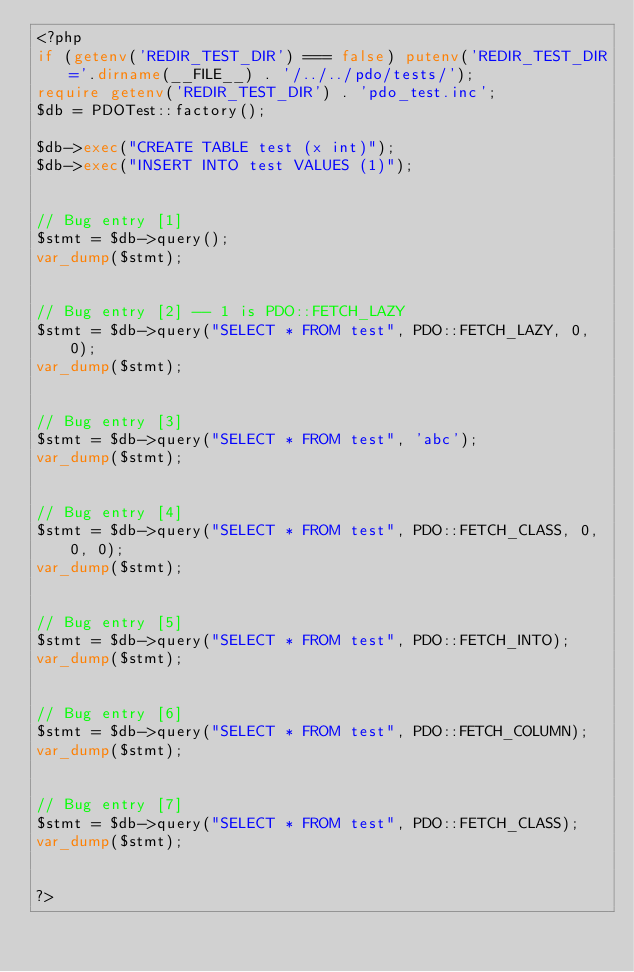Convert code to text. <code><loc_0><loc_0><loc_500><loc_500><_PHP_><?php
if (getenv('REDIR_TEST_DIR') === false) putenv('REDIR_TEST_DIR='.dirname(__FILE__) . '/../../pdo/tests/');
require getenv('REDIR_TEST_DIR') . 'pdo_test.inc';
$db = PDOTest::factory();

$db->exec("CREATE TABLE test (x int)");
$db->exec("INSERT INTO test VALUES (1)");


// Bug entry [1]
$stmt = $db->query();
var_dump($stmt);


// Bug entry [2] -- 1 is PDO::FETCH_LAZY
$stmt = $db->query("SELECT * FROM test", PDO::FETCH_LAZY, 0, 0);
var_dump($stmt);


// Bug entry [3]
$stmt = $db->query("SELECT * FROM test", 'abc');
var_dump($stmt);


// Bug entry [4]
$stmt = $db->query("SELECT * FROM test", PDO::FETCH_CLASS, 0, 0, 0);
var_dump($stmt);


// Bug entry [5]
$stmt = $db->query("SELECT * FROM test", PDO::FETCH_INTO);
var_dump($stmt);


// Bug entry [6]
$stmt = $db->query("SELECT * FROM test", PDO::FETCH_COLUMN);
var_dump($stmt);


// Bug entry [7]
$stmt = $db->query("SELECT * FROM test", PDO::FETCH_CLASS);
var_dump($stmt);


?>
</code> 